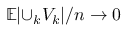<formula> <loc_0><loc_0><loc_500><loc_500>\mathbb { E } { | \cup _ { k } V _ { k } | } / n \rightarrow 0</formula> 